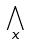Convert formula to latex. <formula><loc_0><loc_0><loc_500><loc_500>\bigwedge _ { x }</formula> 